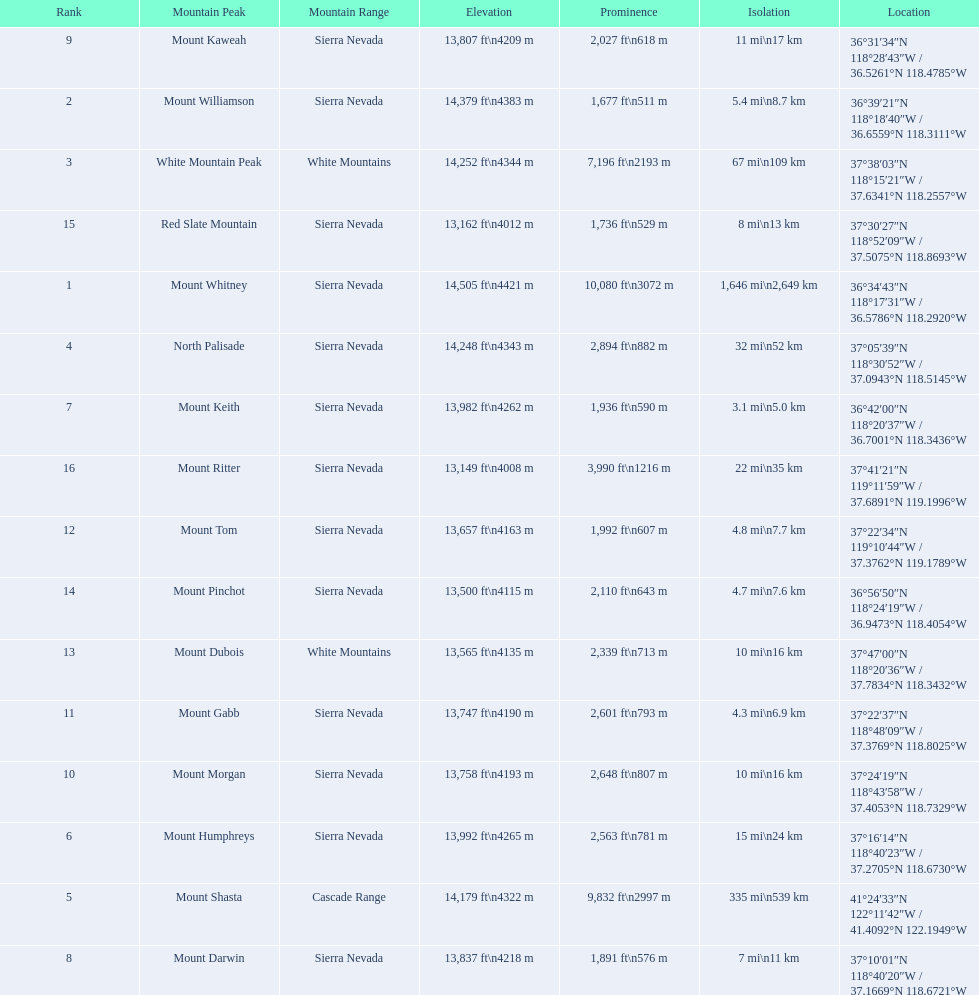What are the peaks in california? Mount Whitney, Mount Williamson, White Mountain Peak, North Palisade, Mount Shasta, Mount Humphreys, Mount Keith, Mount Darwin, Mount Kaweah, Mount Morgan, Mount Gabb, Mount Tom, Mount Dubois, Mount Pinchot, Red Slate Mountain, Mount Ritter. What are the peaks in sierra nevada, california? Mount Whitney, Mount Williamson, North Palisade, Mount Humphreys, Mount Keith, Mount Darwin, Mount Kaweah, Mount Morgan, Mount Gabb, Mount Tom, Mount Pinchot, Red Slate Mountain, Mount Ritter. What are the heights of the peaks in sierra nevada? 14,505 ft\n4421 m, 14,379 ft\n4383 m, 14,248 ft\n4343 m, 13,992 ft\n4265 m, 13,982 ft\n4262 m, 13,837 ft\n4218 m, 13,807 ft\n4209 m, 13,758 ft\n4193 m, 13,747 ft\n4190 m, 13,657 ft\n4163 m, 13,500 ft\n4115 m, 13,162 ft\n4012 m, 13,149 ft\n4008 m. Which is the highest? Mount Whitney. 